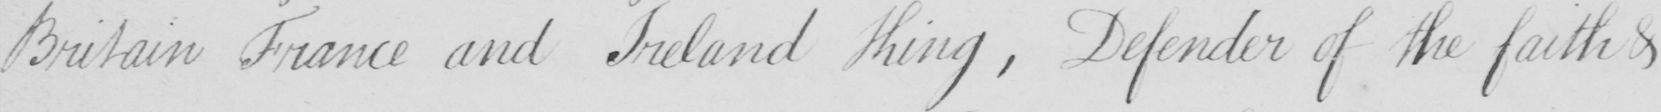Please provide the text content of this handwritten line. Britain France and Ireland King  , Defender of the faith & 